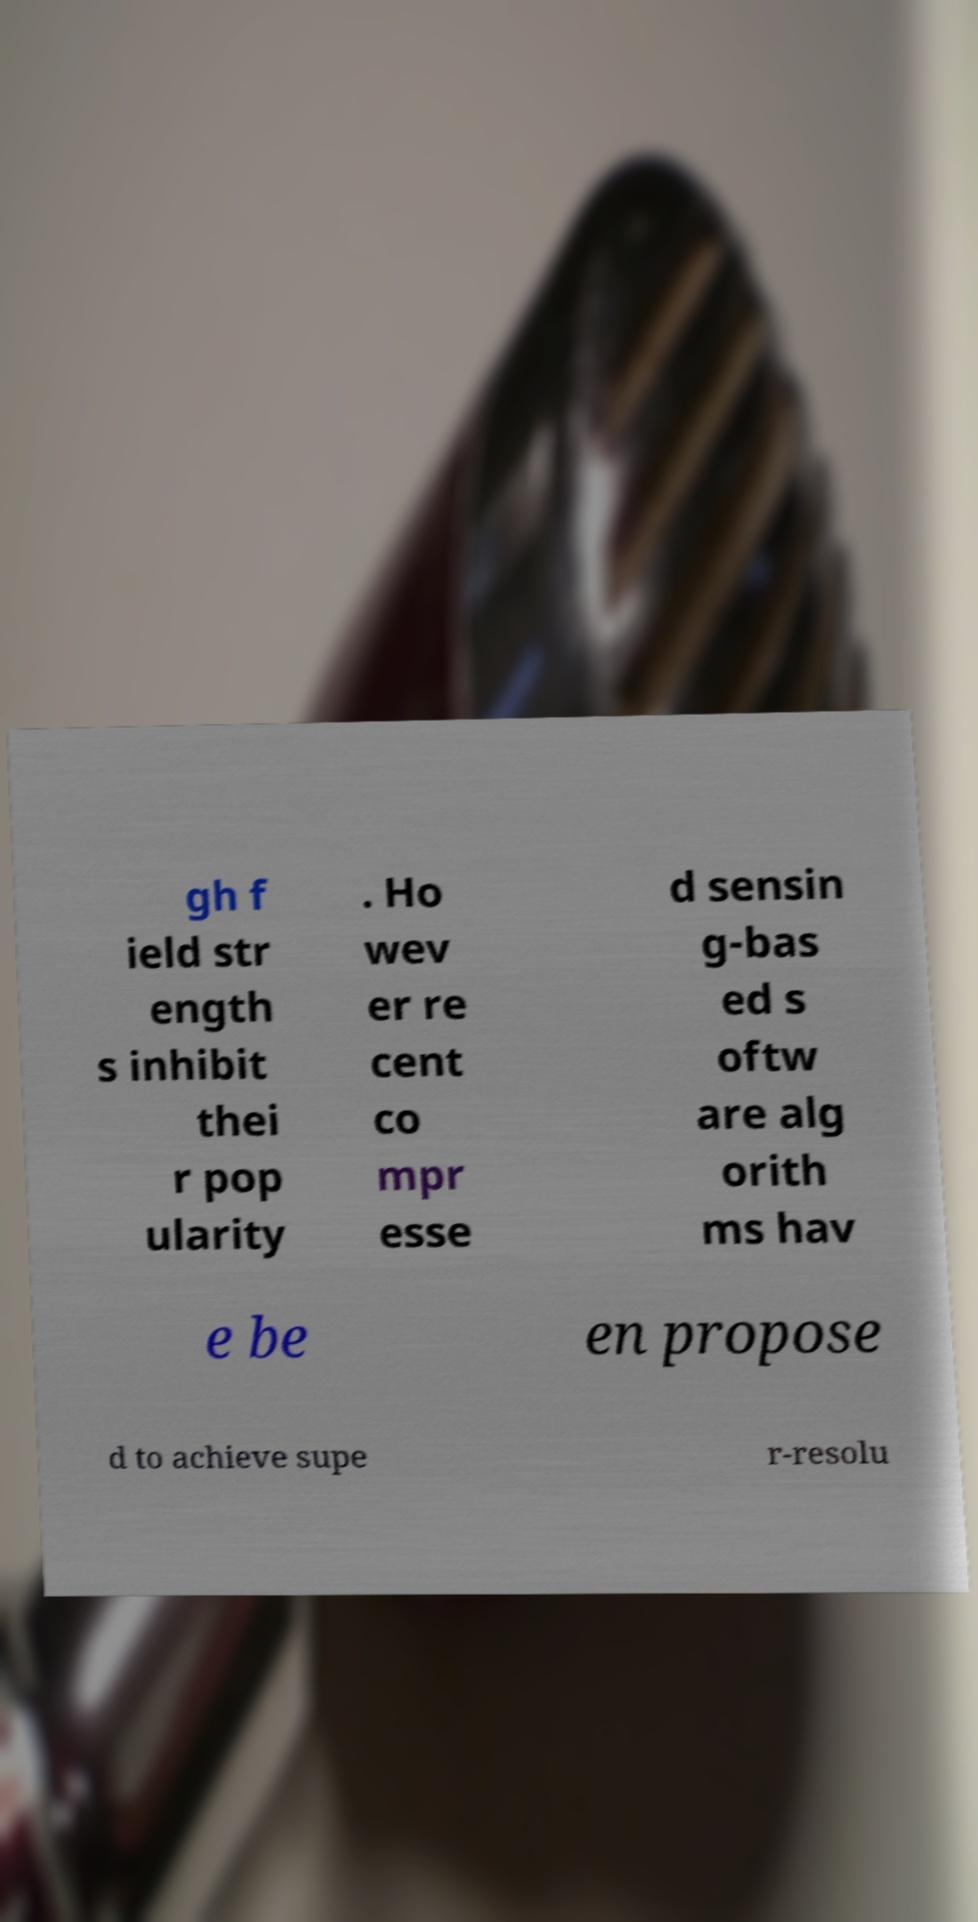Can you read and provide the text displayed in the image?This photo seems to have some interesting text. Can you extract and type it out for me? gh f ield str ength s inhibit thei r pop ularity . Ho wev er re cent co mpr esse d sensin g-bas ed s oftw are alg orith ms hav e be en propose d to achieve supe r-resolu 